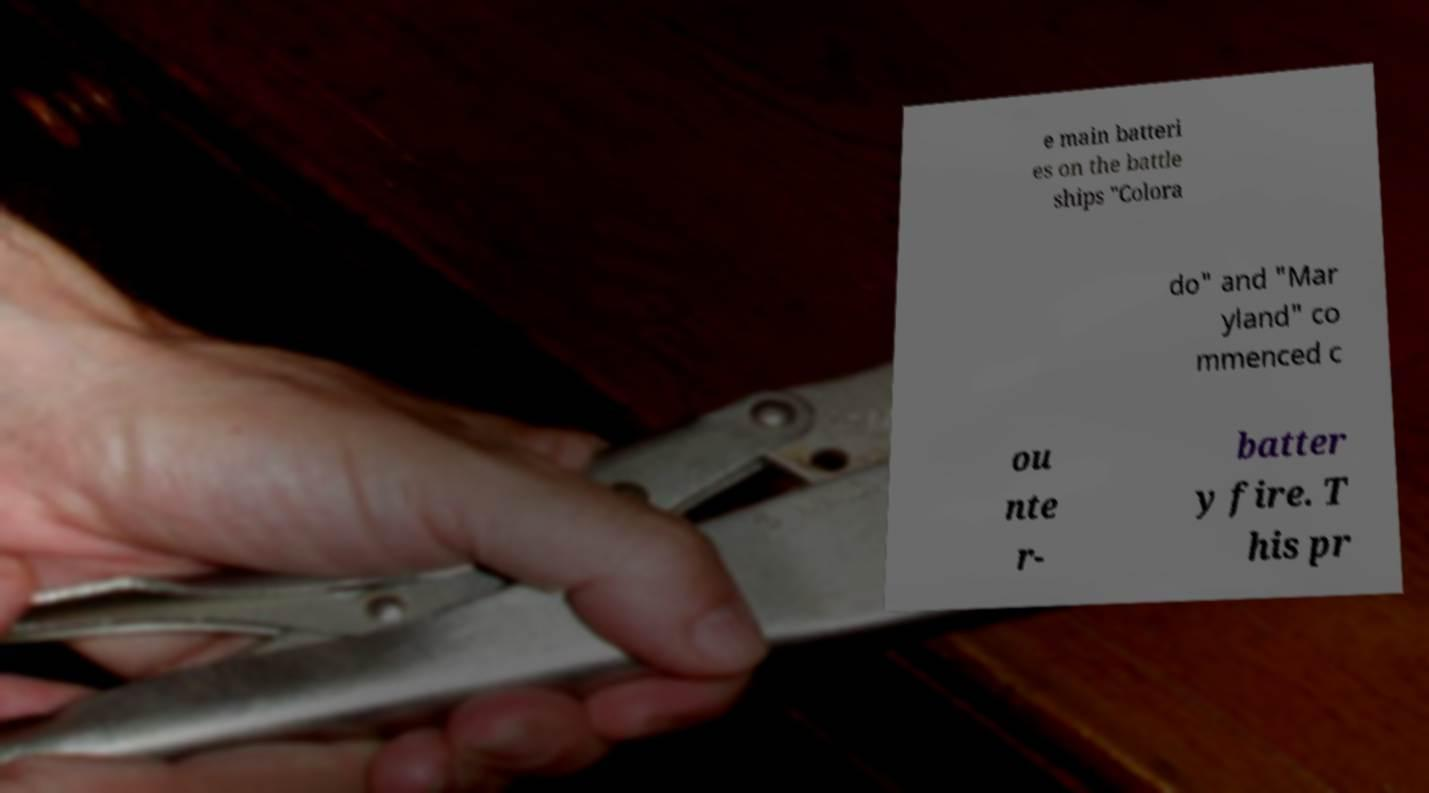There's text embedded in this image that I need extracted. Can you transcribe it verbatim? e main batteri es on the battle ships "Colora do" and "Mar yland" co mmenced c ou nte r- batter y fire. T his pr 